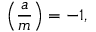Convert formula to latex. <formula><loc_0><loc_0><loc_500><loc_500>\left ( { \frac { a } { m } } \right ) = - 1 ,</formula> 